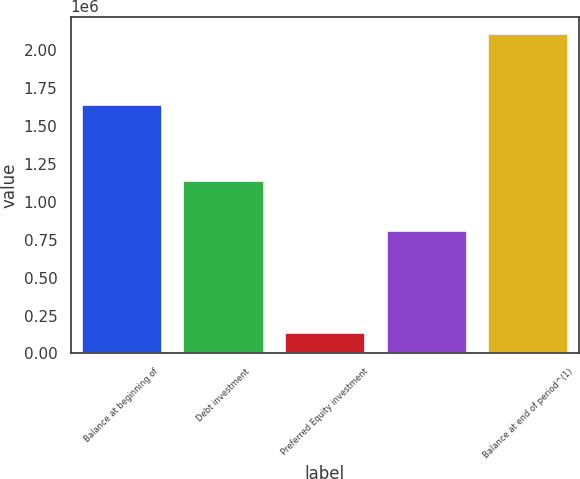<chart> <loc_0><loc_0><loc_500><loc_500><bar_chart><fcel>Balance at beginning of<fcel>Debt investment<fcel>Preferred Equity investment<fcel>Unnamed: 3<fcel>Balance at end of period^(1)<nl><fcel>1.64041e+06<fcel>1.14259e+06<fcel>144456<fcel>813418<fcel>2.11404e+06<nl></chart> 